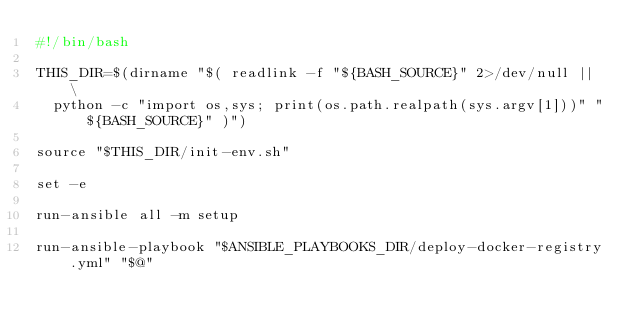Convert code to text. <code><loc_0><loc_0><loc_500><loc_500><_Bash_>#!/bin/bash

THIS_DIR=$(dirname "$( readlink -f "${BASH_SOURCE}" 2>/dev/null || \
  python -c "import os,sys; print(os.path.realpath(sys.argv[1]))" "${BASH_SOURCE}" )")

source "$THIS_DIR/init-env.sh"

set -e

run-ansible all -m setup

run-ansible-playbook "$ANSIBLE_PLAYBOOKS_DIR/deploy-docker-registry.yml" "$@"
</code> 